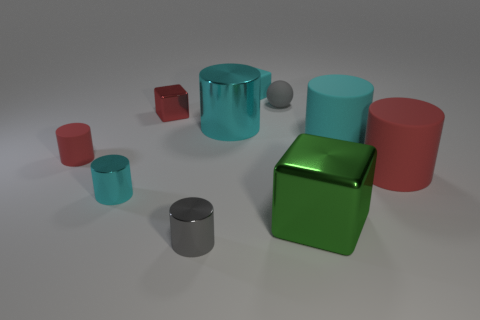What number of objects are either cyan matte blocks or cylinders left of the green shiny block?
Give a very brief answer. 5. There is a big red matte object; what shape is it?
Provide a short and direct response. Cylinder. Is the color of the small matte cylinder the same as the small shiny block?
Provide a succinct answer. Yes. There is a shiny thing that is the same size as the green block; what color is it?
Offer a very short reply. Cyan. What number of purple things are either shiny cylinders or small metal cylinders?
Make the answer very short. 0. Is the number of green matte objects greater than the number of cyan blocks?
Provide a succinct answer. No. Is the size of the thing in front of the big green block the same as the red rubber cylinder that is left of the green thing?
Your response must be concise. Yes. What color is the big cylinder in front of the red cylinder left of the small block that is in front of the gray rubber sphere?
Your answer should be compact. Red. Is there a small brown rubber thing of the same shape as the red shiny object?
Provide a succinct answer. No. Is the number of red rubber things that are on the right side of the tiny red rubber cylinder greater than the number of big purple spheres?
Provide a short and direct response. Yes. 